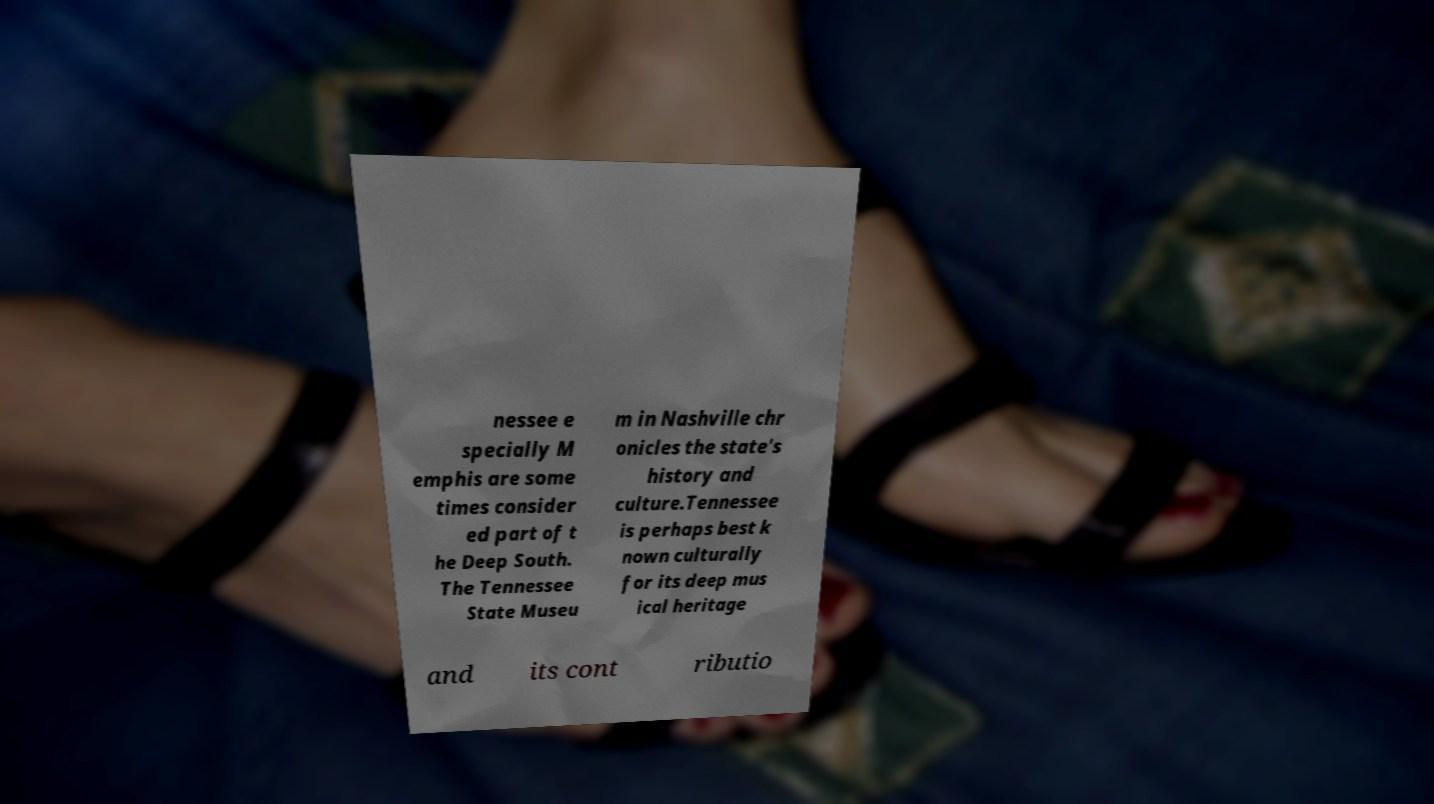There's text embedded in this image that I need extracted. Can you transcribe it verbatim? nessee e specially M emphis are some times consider ed part of t he Deep South. The Tennessee State Museu m in Nashville chr onicles the state's history and culture.Tennessee is perhaps best k nown culturally for its deep mus ical heritage and its cont ributio 